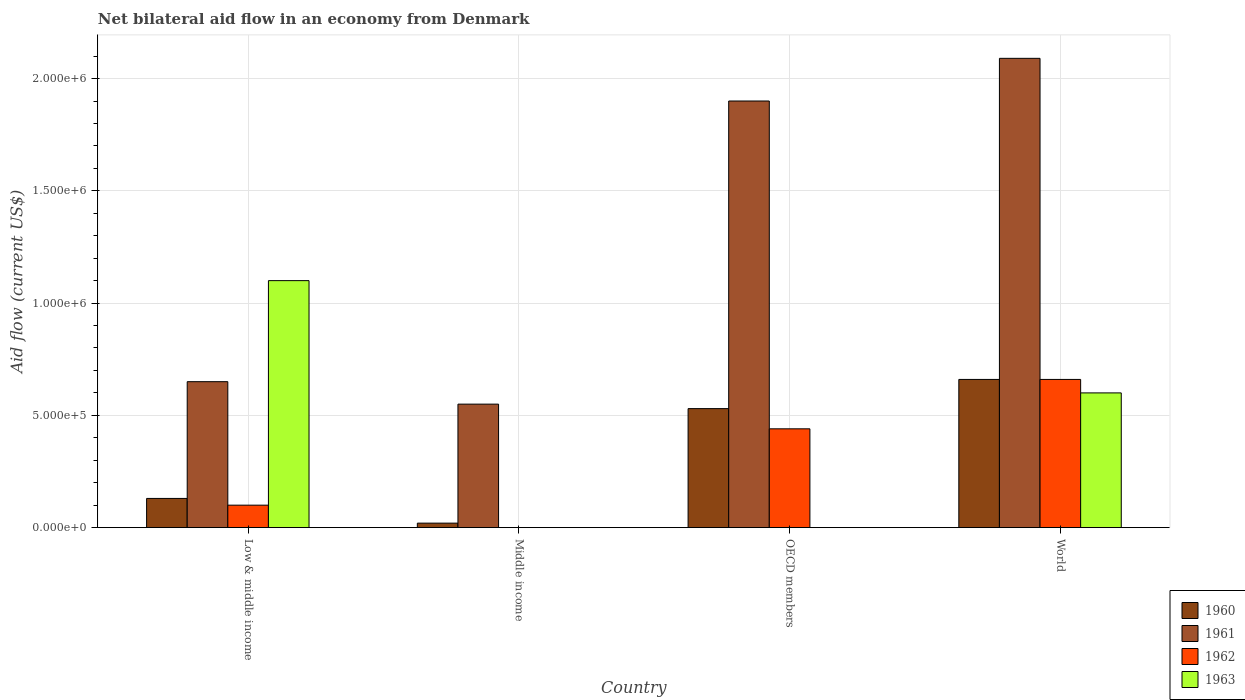How many groups of bars are there?
Give a very brief answer. 4. In how many cases, is the number of bars for a given country not equal to the number of legend labels?
Offer a very short reply. 2. What is the net bilateral aid flow in 1960 in Middle income?
Ensure brevity in your answer.  2.00e+04. Across all countries, what is the maximum net bilateral aid flow in 1960?
Ensure brevity in your answer.  6.60e+05. In which country was the net bilateral aid flow in 1962 maximum?
Provide a short and direct response. World. What is the total net bilateral aid flow in 1961 in the graph?
Your response must be concise. 5.19e+06. What is the difference between the net bilateral aid flow in 1961 in Low & middle income and that in World?
Ensure brevity in your answer.  -1.44e+06. What is the difference between the net bilateral aid flow of/in 1962 and net bilateral aid flow of/in 1963 in World?
Ensure brevity in your answer.  6.00e+04. In how many countries, is the net bilateral aid flow in 1960 greater than 600000 US$?
Offer a terse response. 1. What is the ratio of the net bilateral aid flow in 1960 in Middle income to that in OECD members?
Make the answer very short. 0.04. What is the difference between the highest and the lowest net bilateral aid flow in 1963?
Your answer should be compact. 1.10e+06. In how many countries, is the net bilateral aid flow in 1961 greater than the average net bilateral aid flow in 1961 taken over all countries?
Your answer should be very brief. 2. Is the sum of the net bilateral aid flow in 1960 in Low & middle income and World greater than the maximum net bilateral aid flow in 1962 across all countries?
Ensure brevity in your answer.  Yes. Is it the case that in every country, the sum of the net bilateral aid flow in 1962 and net bilateral aid flow in 1960 is greater than the net bilateral aid flow in 1963?
Your answer should be very brief. No. How many bars are there?
Offer a terse response. 13. Are all the bars in the graph horizontal?
Keep it short and to the point. No. How many countries are there in the graph?
Your answer should be very brief. 4. What is the difference between two consecutive major ticks on the Y-axis?
Your answer should be compact. 5.00e+05. Does the graph contain any zero values?
Give a very brief answer. Yes. What is the title of the graph?
Offer a very short reply. Net bilateral aid flow in an economy from Denmark. What is the label or title of the X-axis?
Offer a terse response. Country. What is the Aid flow (current US$) in 1961 in Low & middle income?
Provide a succinct answer. 6.50e+05. What is the Aid flow (current US$) of 1962 in Low & middle income?
Give a very brief answer. 1.00e+05. What is the Aid flow (current US$) of 1963 in Low & middle income?
Give a very brief answer. 1.10e+06. What is the Aid flow (current US$) in 1961 in Middle income?
Provide a succinct answer. 5.50e+05. What is the Aid flow (current US$) of 1963 in Middle income?
Ensure brevity in your answer.  0. What is the Aid flow (current US$) of 1960 in OECD members?
Give a very brief answer. 5.30e+05. What is the Aid flow (current US$) of 1961 in OECD members?
Provide a succinct answer. 1.90e+06. What is the Aid flow (current US$) in 1962 in OECD members?
Offer a very short reply. 4.40e+05. What is the Aid flow (current US$) of 1963 in OECD members?
Provide a succinct answer. 0. What is the Aid flow (current US$) of 1960 in World?
Provide a succinct answer. 6.60e+05. What is the Aid flow (current US$) in 1961 in World?
Your answer should be very brief. 2.09e+06. Across all countries, what is the maximum Aid flow (current US$) in 1961?
Give a very brief answer. 2.09e+06. Across all countries, what is the maximum Aid flow (current US$) in 1963?
Give a very brief answer. 1.10e+06. Across all countries, what is the minimum Aid flow (current US$) of 1961?
Offer a very short reply. 5.50e+05. Across all countries, what is the minimum Aid flow (current US$) of 1962?
Your response must be concise. 0. What is the total Aid flow (current US$) of 1960 in the graph?
Your response must be concise. 1.34e+06. What is the total Aid flow (current US$) in 1961 in the graph?
Keep it short and to the point. 5.19e+06. What is the total Aid flow (current US$) in 1962 in the graph?
Provide a succinct answer. 1.20e+06. What is the total Aid flow (current US$) of 1963 in the graph?
Your response must be concise. 1.70e+06. What is the difference between the Aid flow (current US$) of 1960 in Low & middle income and that in Middle income?
Offer a terse response. 1.10e+05. What is the difference between the Aid flow (current US$) of 1960 in Low & middle income and that in OECD members?
Offer a very short reply. -4.00e+05. What is the difference between the Aid flow (current US$) of 1961 in Low & middle income and that in OECD members?
Provide a short and direct response. -1.25e+06. What is the difference between the Aid flow (current US$) of 1962 in Low & middle income and that in OECD members?
Your answer should be compact. -3.40e+05. What is the difference between the Aid flow (current US$) of 1960 in Low & middle income and that in World?
Your answer should be compact. -5.30e+05. What is the difference between the Aid flow (current US$) in 1961 in Low & middle income and that in World?
Make the answer very short. -1.44e+06. What is the difference between the Aid flow (current US$) of 1962 in Low & middle income and that in World?
Offer a very short reply. -5.60e+05. What is the difference between the Aid flow (current US$) of 1963 in Low & middle income and that in World?
Your answer should be compact. 5.00e+05. What is the difference between the Aid flow (current US$) of 1960 in Middle income and that in OECD members?
Offer a very short reply. -5.10e+05. What is the difference between the Aid flow (current US$) of 1961 in Middle income and that in OECD members?
Your answer should be compact. -1.35e+06. What is the difference between the Aid flow (current US$) in 1960 in Middle income and that in World?
Your response must be concise. -6.40e+05. What is the difference between the Aid flow (current US$) in 1961 in Middle income and that in World?
Provide a short and direct response. -1.54e+06. What is the difference between the Aid flow (current US$) of 1960 in OECD members and that in World?
Give a very brief answer. -1.30e+05. What is the difference between the Aid flow (current US$) in 1961 in OECD members and that in World?
Make the answer very short. -1.90e+05. What is the difference between the Aid flow (current US$) in 1962 in OECD members and that in World?
Make the answer very short. -2.20e+05. What is the difference between the Aid flow (current US$) of 1960 in Low & middle income and the Aid flow (current US$) of 1961 in Middle income?
Provide a succinct answer. -4.20e+05. What is the difference between the Aid flow (current US$) in 1960 in Low & middle income and the Aid flow (current US$) in 1961 in OECD members?
Make the answer very short. -1.77e+06. What is the difference between the Aid flow (current US$) of 1960 in Low & middle income and the Aid flow (current US$) of 1962 in OECD members?
Provide a succinct answer. -3.10e+05. What is the difference between the Aid flow (current US$) of 1960 in Low & middle income and the Aid flow (current US$) of 1961 in World?
Provide a succinct answer. -1.96e+06. What is the difference between the Aid flow (current US$) of 1960 in Low & middle income and the Aid flow (current US$) of 1962 in World?
Your answer should be very brief. -5.30e+05. What is the difference between the Aid flow (current US$) of 1960 in Low & middle income and the Aid flow (current US$) of 1963 in World?
Keep it short and to the point. -4.70e+05. What is the difference between the Aid flow (current US$) of 1961 in Low & middle income and the Aid flow (current US$) of 1963 in World?
Provide a succinct answer. 5.00e+04. What is the difference between the Aid flow (current US$) in 1962 in Low & middle income and the Aid flow (current US$) in 1963 in World?
Offer a very short reply. -5.00e+05. What is the difference between the Aid flow (current US$) of 1960 in Middle income and the Aid flow (current US$) of 1961 in OECD members?
Your answer should be compact. -1.88e+06. What is the difference between the Aid flow (current US$) in 1960 in Middle income and the Aid flow (current US$) in 1962 in OECD members?
Give a very brief answer. -4.20e+05. What is the difference between the Aid flow (current US$) of 1961 in Middle income and the Aid flow (current US$) of 1962 in OECD members?
Give a very brief answer. 1.10e+05. What is the difference between the Aid flow (current US$) in 1960 in Middle income and the Aid flow (current US$) in 1961 in World?
Your response must be concise. -2.07e+06. What is the difference between the Aid flow (current US$) of 1960 in Middle income and the Aid flow (current US$) of 1962 in World?
Ensure brevity in your answer.  -6.40e+05. What is the difference between the Aid flow (current US$) in 1960 in Middle income and the Aid flow (current US$) in 1963 in World?
Provide a short and direct response. -5.80e+05. What is the difference between the Aid flow (current US$) in 1961 in Middle income and the Aid flow (current US$) in 1963 in World?
Ensure brevity in your answer.  -5.00e+04. What is the difference between the Aid flow (current US$) of 1960 in OECD members and the Aid flow (current US$) of 1961 in World?
Provide a succinct answer. -1.56e+06. What is the difference between the Aid flow (current US$) in 1960 in OECD members and the Aid flow (current US$) in 1963 in World?
Offer a very short reply. -7.00e+04. What is the difference between the Aid flow (current US$) of 1961 in OECD members and the Aid flow (current US$) of 1962 in World?
Your response must be concise. 1.24e+06. What is the difference between the Aid flow (current US$) in 1961 in OECD members and the Aid flow (current US$) in 1963 in World?
Offer a very short reply. 1.30e+06. What is the average Aid flow (current US$) of 1960 per country?
Provide a short and direct response. 3.35e+05. What is the average Aid flow (current US$) of 1961 per country?
Your answer should be compact. 1.30e+06. What is the average Aid flow (current US$) of 1963 per country?
Provide a succinct answer. 4.25e+05. What is the difference between the Aid flow (current US$) in 1960 and Aid flow (current US$) in 1961 in Low & middle income?
Provide a short and direct response. -5.20e+05. What is the difference between the Aid flow (current US$) of 1960 and Aid flow (current US$) of 1962 in Low & middle income?
Give a very brief answer. 3.00e+04. What is the difference between the Aid flow (current US$) of 1960 and Aid flow (current US$) of 1963 in Low & middle income?
Give a very brief answer. -9.70e+05. What is the difference between the Aid flow (current US$) in 1961 and Aid flow (current US$) in 1963 in Low & middle income?
Your answer should be very brief. -4.50e+05. What is the difference between the Aid flow (current US$) of 1960 and Aid flow (current US$) of 1961 in Middle income?
Offer a very short reply. -5.30e+05. What is the difference between the Aid flow (current US$) of 1960 and Aid flow (current US$) of 1961 in OECD members?
Your response must be concise. -1.37e+06. What is the difference between the Aid flow (current US$) of 1961 and Aid flow (current US$) of 1962 in OECD members?
Keep it short and to the point. 1.46e+06. What is the difference between the Aid flow (current US$) of 1960 and Aid flow (current US$) of 1961 in World?
Make the answer very short. -1.43e+06. What is the difference between the Aid flow (current US$) of 1960 and Aid flow (current US$) of 1962 in World?
Your response must be concise. 0. What is the difference between the Aid flow (current US$) of 1961 and Aid flow (current US$) of 1962 in World?
Provide a succinct answer. 1.43e+06. What is the difference between the Aid flow (current US$) in 1961 and Aid flow (current US$) in 1963 in World?
Your answer should be compact. 1.49e+06. What is the ratio of the Aid flow (current US$) in 1961 in Low & middle income to that in Middle income?
Give a very brief answer. 1.18. What is the ratio of the Aid flow (current US$) in 1960 in Low & middle income to that in OECD members?
Offer a very short reply. 0.25. What is the ratio of the Aid flow (current US$) of 1961 in Low & middle income to that in OECD members?
Provide a succinct answer. 0.34. What is the ratio of the Aid flow (current US$) of 1962 in Low & middle income to that in OECD members?
Keep it short and to the point. 0.23. What is the ratio of the Aid flow (current US$) of 1960 in Low & middle income to that in World?
Give a very brief answer. 0.2. What is the ratio of the Aid flow (current US$) in 1961 in Low & middle income to that in World?
Your answer should be very brief. 0.31. What is the ratio of the Aid flow (current US$) of 1962 in Low & middle income to that in World?
Offer a very short reply. 0.15. What is the ratio of the Aid flow (current US$) of 1963 in Low & middle income to that in World?
Your response must be concise. 1.83. What is the ratio of the Aid flow (current US$) of 1960 in Middle income to that in OECD members?
Provide a short and direct response. 0.04. What is the ratio of the Aid flow (current US$) of 1961 in Middle income to that in OECD members?
Give a very brief answer. 0.29. What is the ratio of the Aid flow (current US$) in 1960 in Middle income to that in World?
Ensure brevity in your answer.  0.03. What is the ratio of the Aid flow (current US$) of 1961 in Middle income to that in World?
Provide a succinct answer. 0.26. What is the ratio of the Aid flow (current US$) in 1960 in OECD members to that in World?
Keep it short and to the point. 0.8. What is the difference between the highest and the second highest Aid flow (current US$) of 1961?
Offer a terse response. 1.90e+05. What is the difference between the highest and the lowest Aid flow (current US$) of 1960?
Provide a short and direct response. 6.40e+05. What is the difference between the highest and the lowest Aid flow (current US$) in 1961?
Keep it short and to the point. 1.54e+06. What is the difference between the highest and the lowest Aid flow (current US$) in 1963?
Your response must be concise. 1.10e+06. 